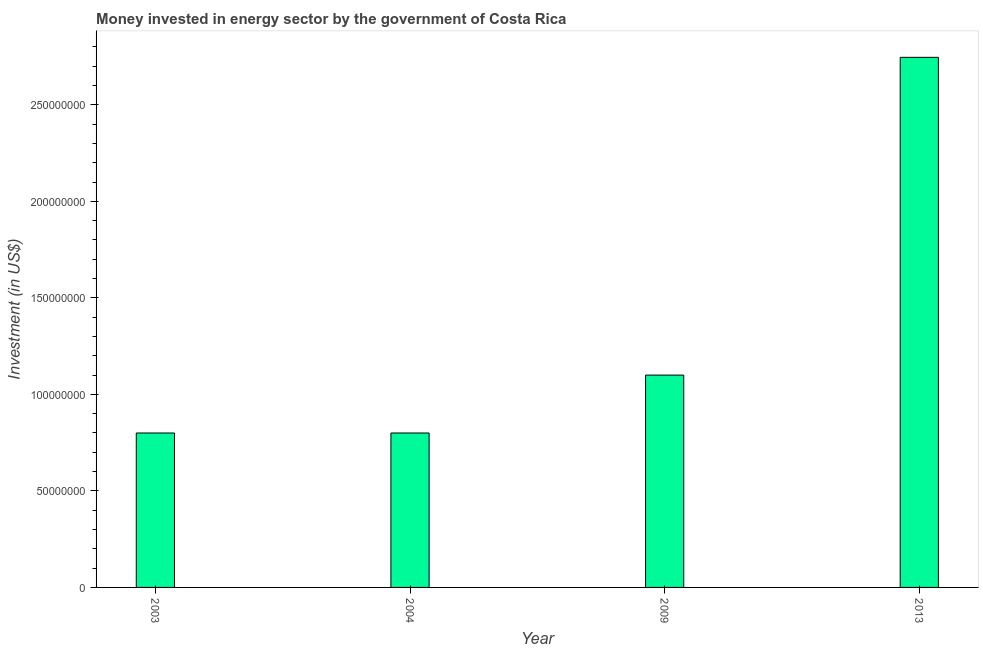Does the graph contain any zero values?
Make the answer very short. No. Does the graph contain grids?
Give a very brief answer. No. What is the title of the graph?
Offer a very short reply. Money invested in energy sector by the government of Costa Rica. What is the label or title of the X-axis?
Your answer should be compact. Year. What is the label or title of the Y-axis?
Ensure brevity in your answer.  Investment (in US$). What is the investment in energy in 2003?
Give a very brief answer. 8.00e+07. Across all years, what is the maximum investment in energy?
Keep it short and to the point. 2.75e+08. Across all years, what is the minimum investment in energy?
Keep it short and to the point. 8.00e+07. In which year was the investment in energy maximum?
Provide a short and direct response. 2013. In which year was the investment in energy minimum?
Keep it short and to the point. 2003. What is the sum of the investment in energy?
Make the answer very short. 5.45e+08. What is the difference between the investment in energy in 2004 and 2013?
Provide a short and direct response. -1.95e+08. What is the average investment in energy per year?
Ensure brevity in your answer.  1.36e+08. What is the median investment in energy?
Offer a very short reply. 9.50e+07. In how many years, is the investment in energy greater than 250000000 US$?
Make the answer very short. 1. Do a majority of the years between 2009 and 2013 (inclusive) have investment in energy greater than 100000000 US$?
Provide a succinct answer. Yes. What is the ratio of the investment in energy in 2004 to that in 2009?
Keep it short and to the point. 0.73. Is the investment in energy in 2004 less than that in 2009?
Keep it short and to the point. Yes. What is the difference between the highest and the second highest investment in energy?
Make the answer very short. 1.65e+08. Is the sum of the investment in energy in 2003 and 2009 greater than the maximum investment in energy across all years?
Your answer should be compact. No. What is the difference between the highest and the lowest investment in energy?
Your response must be concise. 1.95e+08. In how many years, is the investment in energy greater than the average investment in energy taken over all years?
Keep it short and to the point. 1. How many bars are there?
Ensure brevity in your answer.  4. How many years are there in the graph?
Offer a terse response. 4. What is the difference between two consecutive major ticks on the Y-axis?
Your response must be concise. 5.00e+07. What is the Investment (in US$) of 2003?
Your response must be concise. 8.00e+07. What is the Investment (in US$) of 2004?
Ensure brevity in your answer.  8.00e+07. What is the Investment (in US$) of 2009?
Your response must be concise. 1.10e+08. What is the Investment (in US$) in 2013?
Give a very brief answer. 2.75e+08. What is the difference between the Investment (in US$) in 2003 and 2009?
Your answer should be very brief. -3.00e+07. What is the difference between the Investment (in US$) in 2003 and 2013?
Your response must be concise. -1.95e+08. What is the difference between the Investment (in US$) in 2004 and 2009?
Offer a very short reply. -3.00e+07. What is the difference between the Investment (in US$) in 2004 and 2013?
Provide a succinct answer. -1.95e+08. What is the difference between the Investment (in US$) in 2009 and 2013?
Keep it short and to the point. -1.65e+08. What is the ratio of the Investment (in US$) in 2003 to that in 2009?
Offer a very short reply. 0.73. What is the ratio of the Investment (in US$) in 2003 to that in 2013?
Offer a terse response. 0.29. What is the ratio of the Investment (in US$) in 2004 to that in 2009?
Ensure brevity in your answer.  0.73. What is the ratio of the Investment (in US$) in 2004 to that in 2013?
Offer a terse response. 0.29. What is the ratio of the Investment (in US$) in 2009 to that in 2013?
Provide a succinct answer. 0.4. 